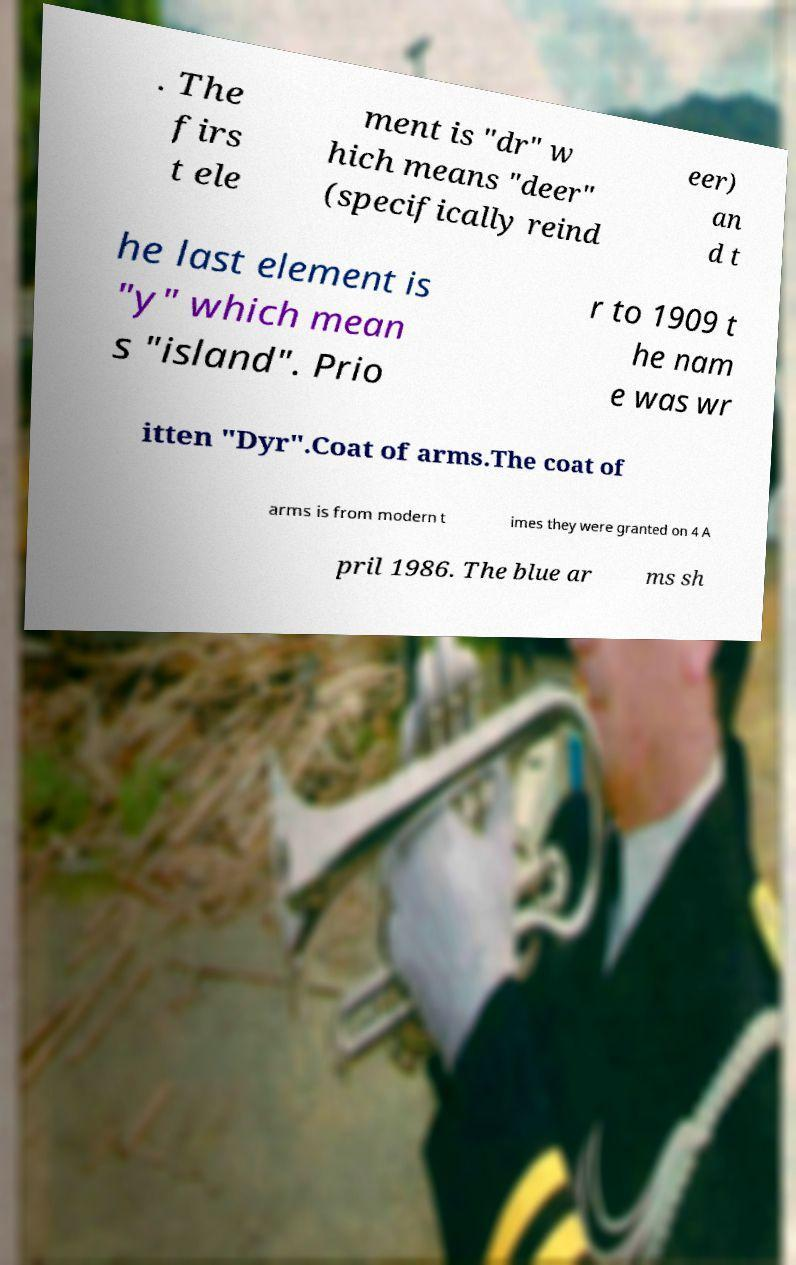Please read and relay the text visible in this image. What does it say? . The firs t ele ment is "dr" w hich means "deer" (specifically reind eer) an d t he last element is "y" which mean s "island". Prio r to 1909 t he nam e was wr itten "Dyr".Coat of arms.The coat of arms is from modern t imes they were granted on 4 A pril 1986. The blue ar ms sh 